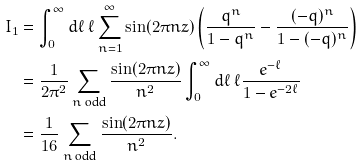Convert formula to latex. <formula><loc_0><loc_0><loc_500><loc_500>I _ { 1 } & = \int _ { 0 } ^ { \infty } d \ell \ \ell \sum _ { n = 1 } ^ { \infty } \sin ( 2 \pi n z ) \left ( \frac { q ^ { n } } { 1 - q ^ { n } } - \frac { ( - q ) ^ { n } } { 1 - ( - q ) ^ { n } } \right ) \\ & = \frac { 1 } { 2 \pi ^ { 2 } } \sum _ { n \text { odd} } \frac { \sin ( 2 \pi n z ) } { n ^ { 2 } } \int _ { 0 } ^ { \infty } d \ell \ \ell \frac { e ^ { - \ell } } { 1 - e ^ { - 2 \ell } } \\ & = \frac { 1 } { 1 6 } \sum _ { n \text { odd} } \frac { \sin ( 2 \pi n z ) } { n ^ { 2 } } .</formula> 